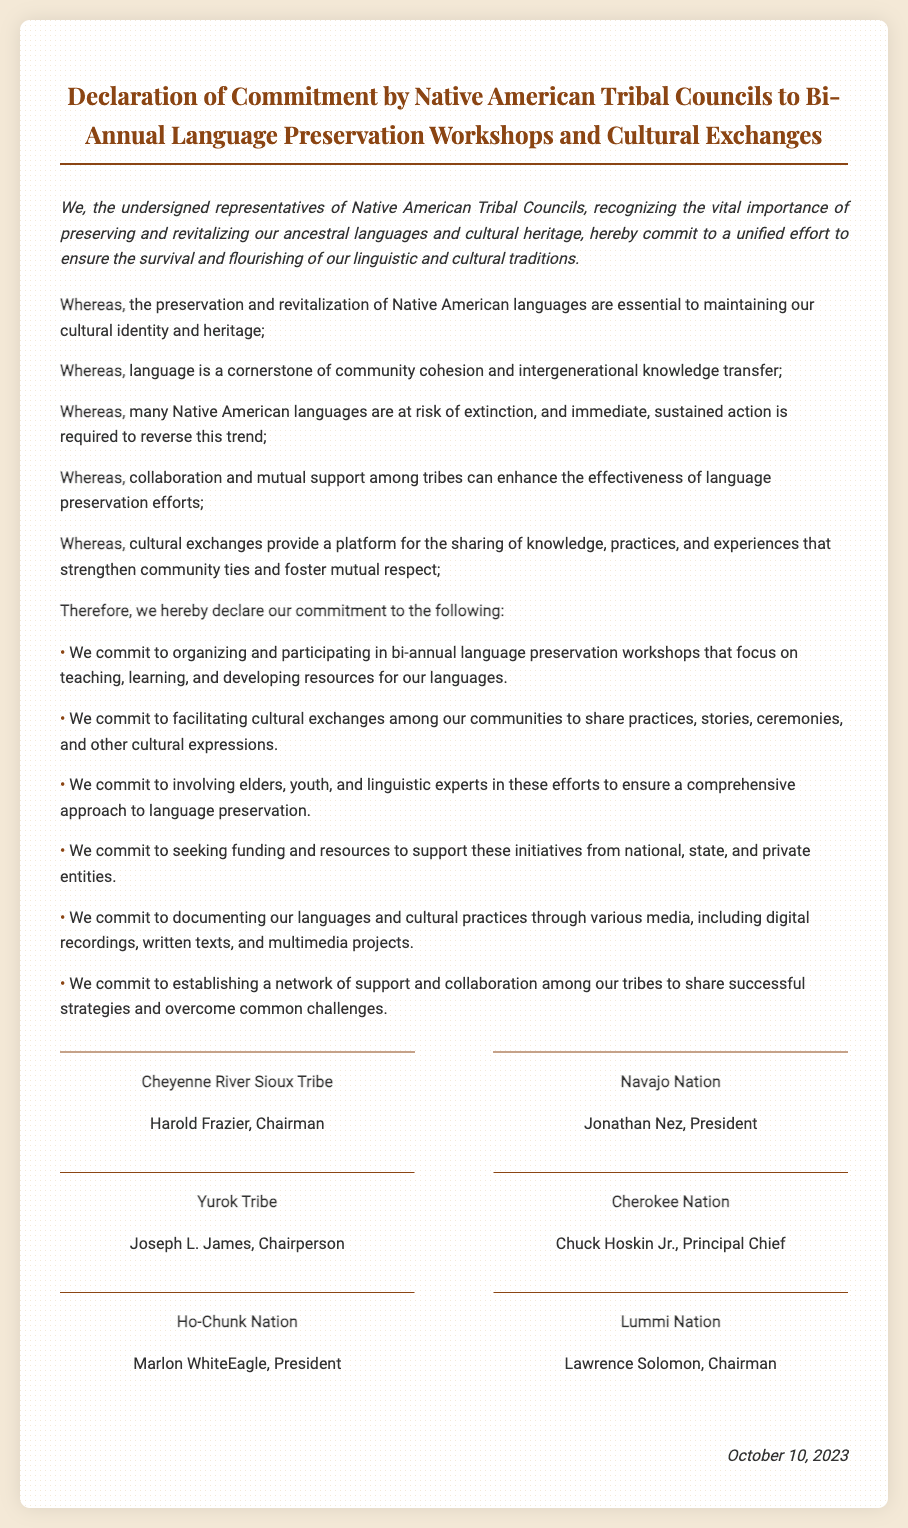What is the title of the document? The title is clearly stated at the top of the document.
Answer: Declaration of Commitment by Native American Tribal Councils to Bi-Annual Language Preservation Workshops and Cultural Exchanges What date was the declaration signed? The date of signing is mentioned at the bottom of the document.
Answer: October 10, 2023 Who is the Chairman of the Cheyenne River Sioux Tribe? This information is found in the signatories section of the document.
Answer: Harold Frazier What is one of the commitments made by the Tribal Councils? The commitments are listed within the document; one example can be chosen.
Answer: Organizing bi-annual language preservation workshops What is emphasized as essential to maintaining cultural identity? This is highlighted in the "whereas" sections.
Answer: Preservation and revitalization of Native American languages How many signatory tribes are listed in the document? The number of tribes can be counted from the signatories section.
Answer: Six Which tribe does Chuck Hoskin Jr. represent? This information can be directly retrieved from the signatories section.
Answer: Cherokee Nation Name one type of media mentioned for documenting languages and cultural practices. The commitments include various media types for documentation.
Answer: Digital recordings What role do elders and youth have in the commitments? The document specifies the involvement of different community members in the efforts.
Answer: Involving elders and youth 